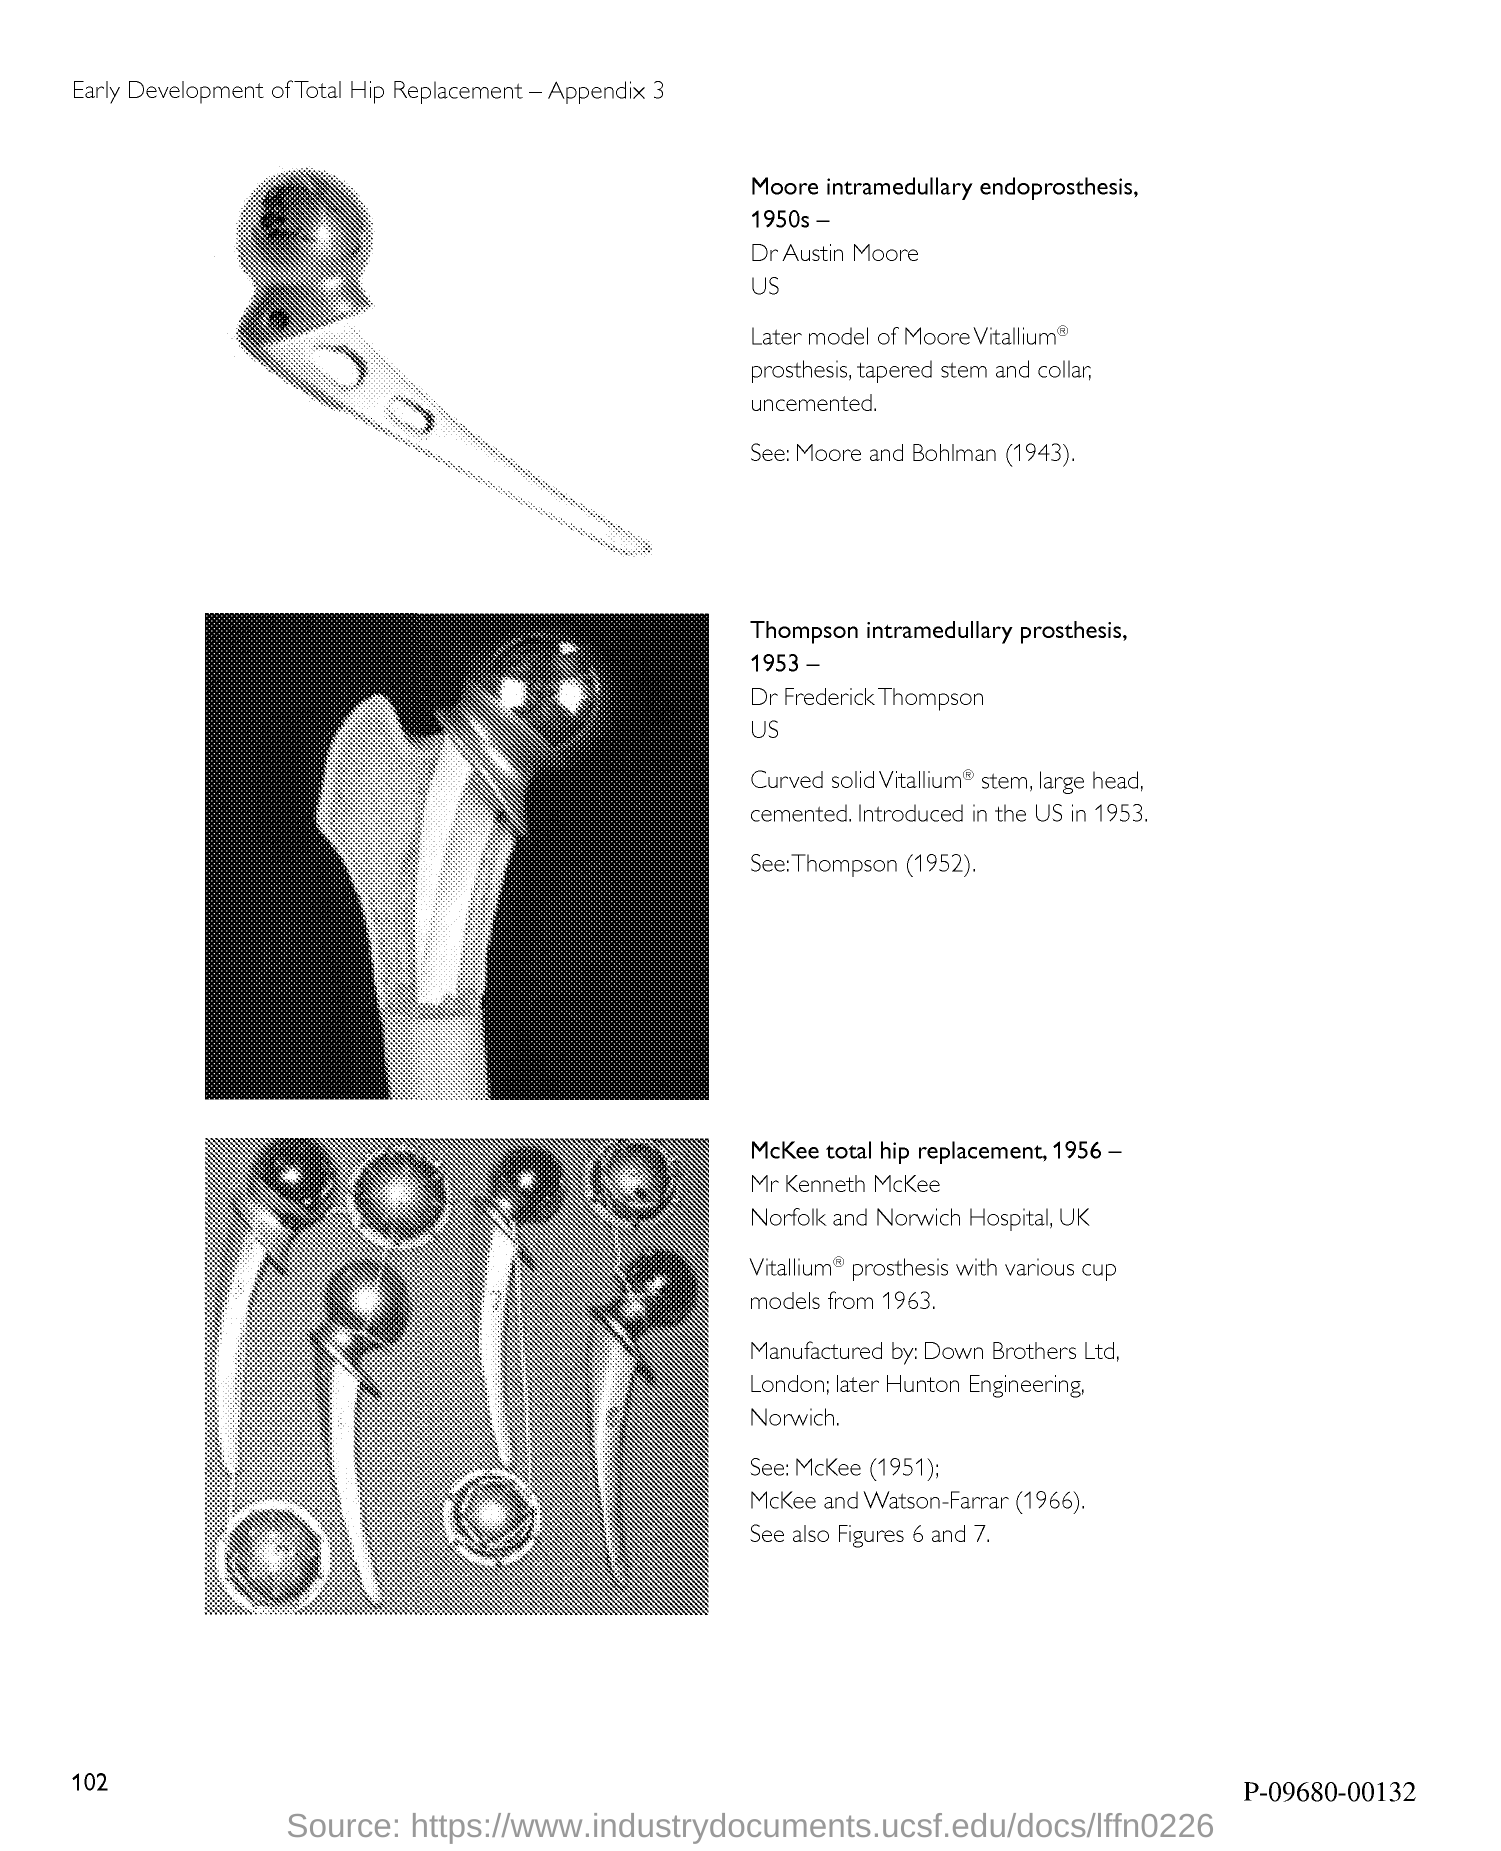Draw attention to some important aspects in this diagram. The number at the bottom-left corner of the page is 102. 